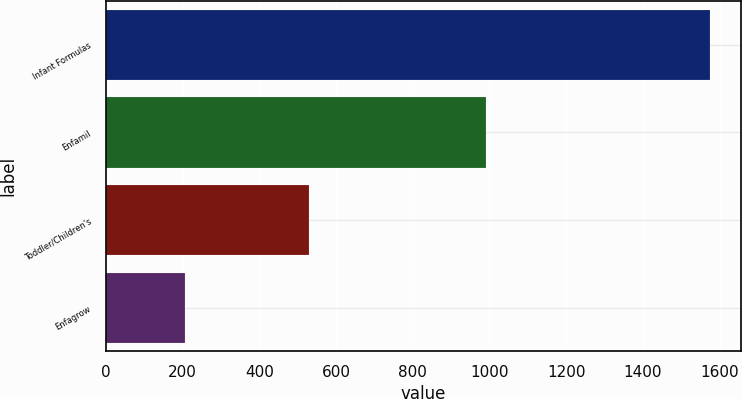Convert chart. <chart><loc_0><loc_0><loc_500><loc_500><bar_chart><fcel>Infant Formulas<fcel>Enfamil<fcel>Toddler/Children's<fcel>Enfagrow<nl><fcel>1576<fcel>992<fcel>529<fcel>206<nl></chart> 